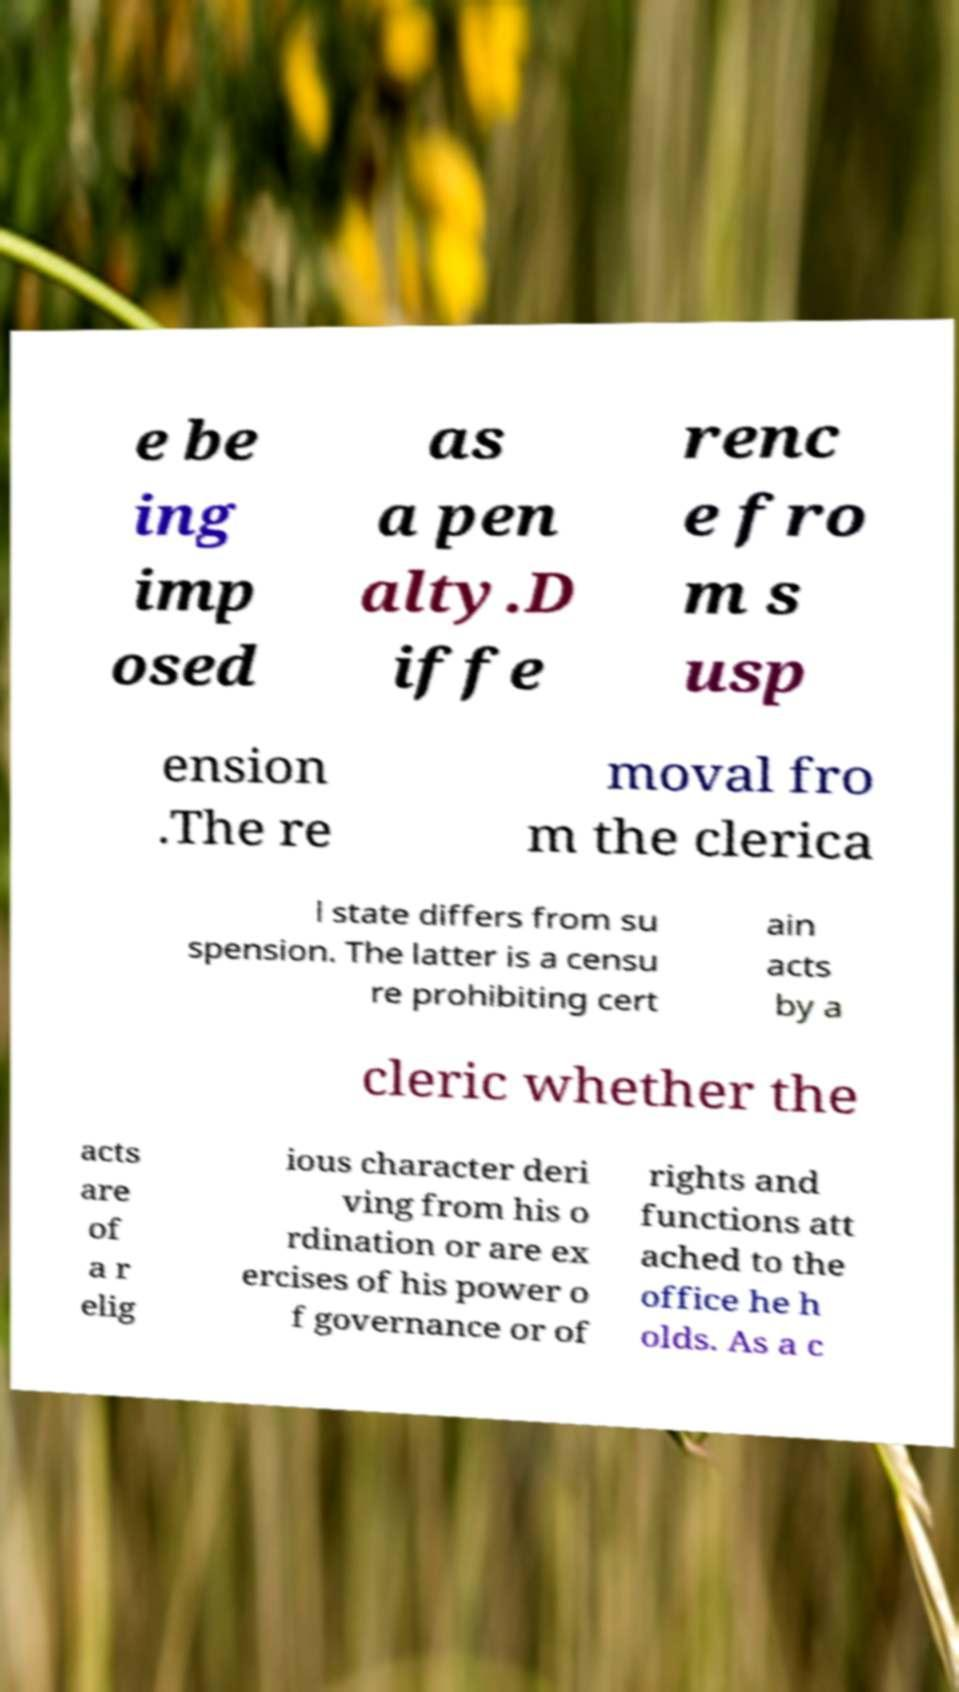There's text embedded in this image that I need extracted. Can you transcribe it verbatim? e be ing imp osed as a pen alty.D iffe renc e fro m s usp ension .The re moval fro m the clerica l state differs from su spension. The latter is a censu re prohibiting cert ain acts by a cleric whether the acts are of a r elig ious character deri ving from his o rdination or are ex ercises of his power o f governance or of rights and functions att ached to the office he h olds. As a c 